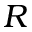<formula> <loc_0><loc_0><loc_500><loc_500>R</formula> 